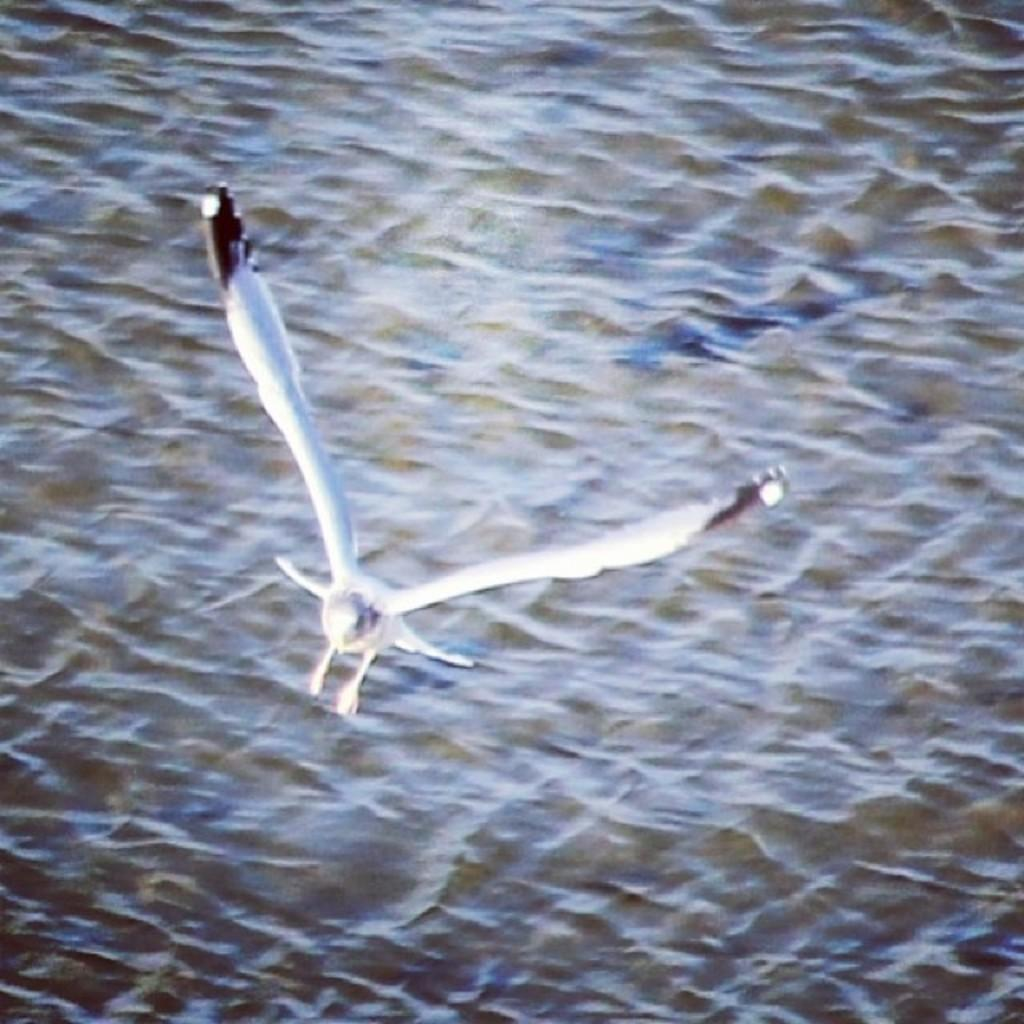What is the main subject of the image? The main subject of the image is a bird flying. What can be seen in the background of the image? There is a water body visible in the background of the image. What type of scarf is the bird wearing while flying in the image? There is no scarf present on the bird in the image. What kind of trouble is the bird causing in the image? There is no indication of the bird causing any trouble in the image. 